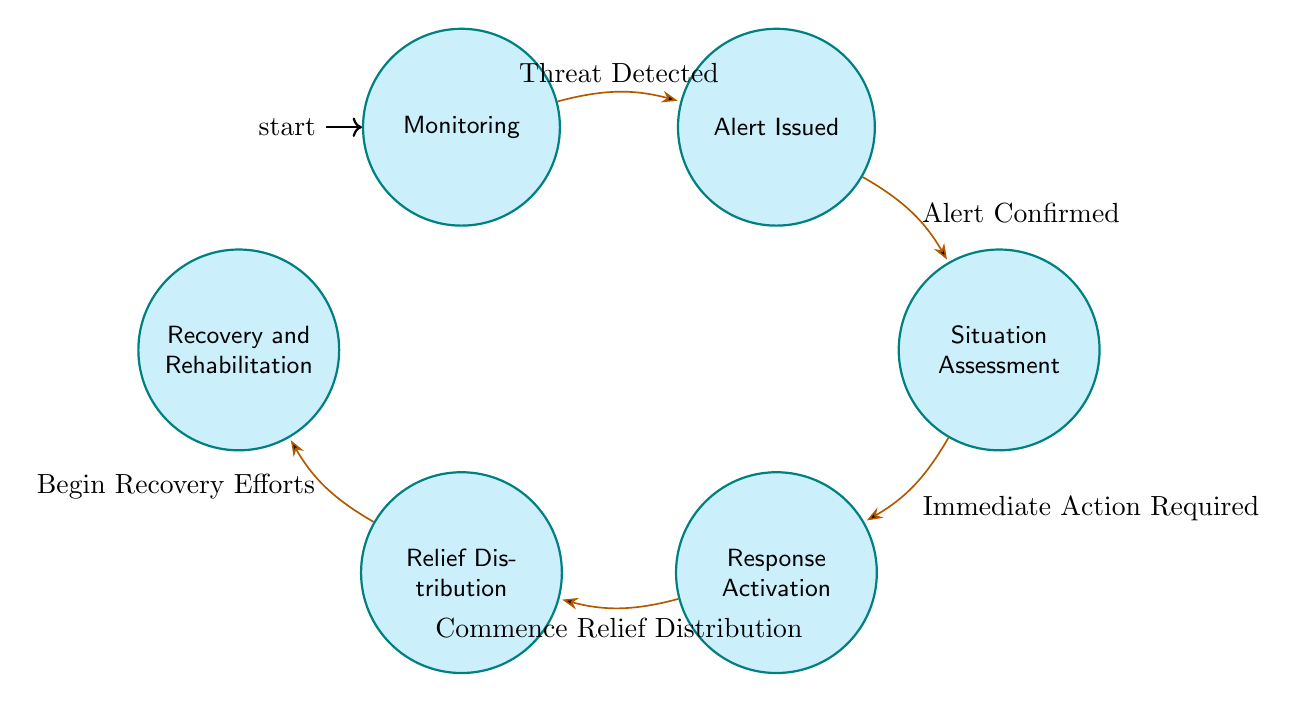What is the first state in the diagram? The first state in the diagram is "Monitoring," as it is indicated as the initial state. This is the starting point before any threats are detected.
Answer: Monitoring How many states are there in the diagram? To find the number of states, we can count the states listed in the diagram: Monitoring, Alert Issued, Situation Assessment, Response Activation, Relief Distribution, and Recovery and Rehabilitation, resulting in a total of six states.
Answer: 6 What is the transition from the "Alert Issued" state? The transition from the "Alert Issued" state is labeled "Alert Confirmed," which indicates the action that takes place when an alert is validated.
Answer: Alert Confirmed What action follows the "Situation Assessment" state? The action that follows the "Situation Assessment" state is "Response Activation," as indicated by the arrow leading from Situation Assessment to Response Activation, representing the need for immediate action after assessing the situation.
Answer: Response Activation Which state is reached after "Relief Distribution"? After "Relief Distribution," the next state reached is "Recovery and Rehabilitation," as per the transition indicating that once relief distribution begins, recovery efforts are initiated afterward.
Answer: Recovery and Rehabilitation What is the purpose of the "Response Activation" state? The purpose of the "Response Activation" state is to activate the emergency response plan, which includes mobilizing resources such as rescue teams, medical supplies, food, and shelter, to assist in disaster response.
Answer: Activate emergency response plan What triggers the transition from "Monitoring" to "Alert Issued"? The transition from "Monitoring" to "Alert Issued" is triggered by the detection of a threat, which indicates that monitoring systems have identified a potential disaster situation that needs action.
Answer: Threat Detected How does the diagram flow from the "Assessment" state? The diagram flows from the "Assessment" state with the condition "Immediate Action Required," leading to "Response Activation," indicating that based on the assessment, action is needed to respond to the situation effectively.
Answer: Immediate Action Required What represents the relationship between "Relief Distribution" and "Recovery and Rehabilitation"? The relationship between "Relief Distribution" and "Recovery and Rehabilitation" is represented by the transition "Begin Recovery Efforts," which indicates that recovery efforts commence following the distribution of relief items to affected populations.
Answer: Begin Recovery Efforts 